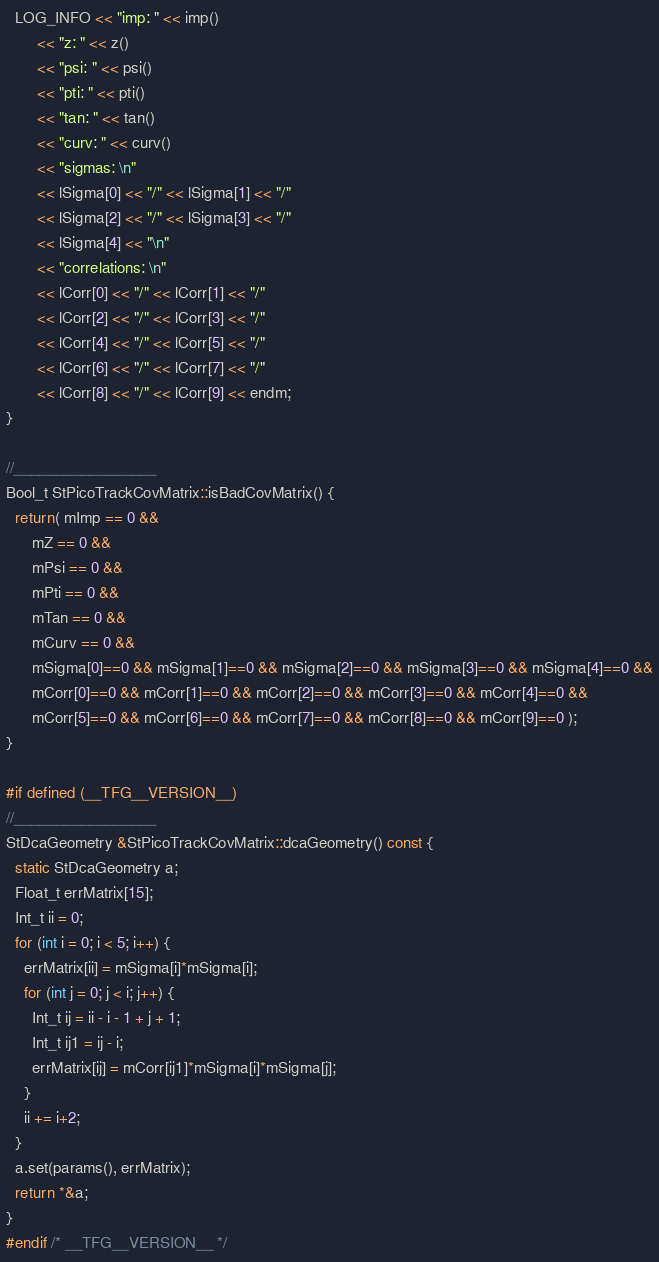<code> <loc_0><loc_0><loc_500><loc_500><_C++_>  LOG_INFO << "imp: " << imp()
	   << "z: " << z()
	   << "psi: " << psi()
	   << "pti: " << pti()
	   << "tan: " << tan()
	   << "curv: " << curv()
	   << "sigmas: \n"
	   << lSigma[0] << "/" << lSigma[1] << "/"
	   << lSigma[2] << "/" << lSigma[3] << "/"
	   << lSigma[4] << "\n"
	   << "correlations: \n"
	   << lCorr[0] << "/" << lCorr[1] << "/"
	   << lCorr[2] << "/" << lCorr[3] << "/"
	   << lCorr[4] << "/" << lCorr[5] << "/"
	   << lCorr[6] << "/" << lCorr[7] << "/"
	   << lCorr[8] << "/" << lCorr[9] << endm;
}

//_________________
Bool_t StPicoTrackCovMatrix::isBadCovMatrix() {
  return( mImp == 0 &&
	  mZ == 0 &&
	  mPsi == 0 &&
	  mPti == 0 &&
	  mTan == 0 &&
	  mCurv == 0 &&
	  mSigma[0]==0 && mSigma[1]==0 && mSigma[2]==0 && mSigma[3]==0 && mSigma[4]==0 &&
	  mCorr[0]==0 && mCorr[1]==0 && mCorr[2]==0 && mCorr[3]==0 && mCorr[4]==0 &&
	  mCorr[5]==0 && mCorr[6]==0 && mCorr[7]==0 && mCorr[8]==0 && mCorr[9]==0 );
}

#if defined (__TFG__VERSION__)
//_________________
StDcaGeometry &StPicoTrackCovMatrix::dcaGeometry() const {
  static StDcaGeometry a;
  Float_t errMatrix[15];
  Int_t ii = 0;
  for (int i = 0; i < 5; i++) {
    errMatrix[ii] = mSigma[i]*mSigma[i];
    for (int j = 0; j < i; j++) {
      Int_t ij = ii - i - 1 + j + 1;
      Int_t ij1 = ij - i;
      errMatrix[ij] = mCorr[ij1]*mSigma[i]*mSigma[j];
    }
    ii += i+2;
  }
  a.set(params(), errMatrix);
  return *&a;
}      
#endif /* __TFG__VERSION__ */
</code> 